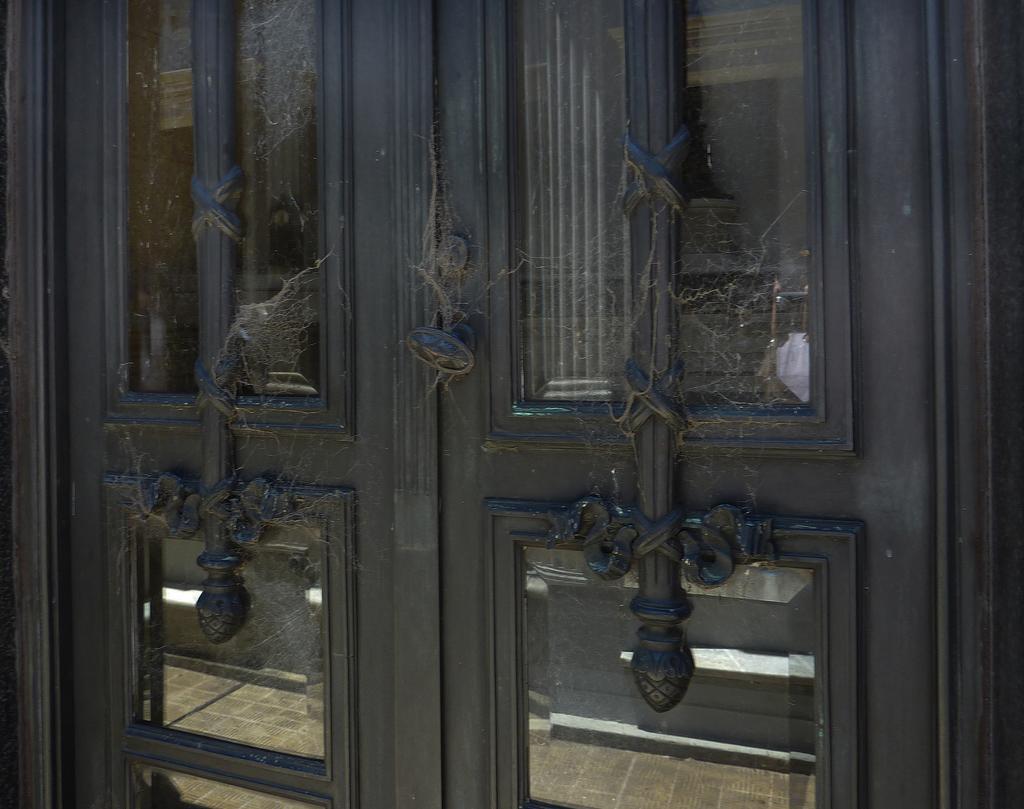Can you describe this image briefly? In this image we can see doors with glass panes. Also there are designs and spider webs. 